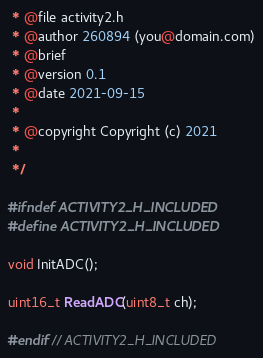<code> <loc_0><loc_0><loc_500><loc_500><_C_> * @file activity2.h
 * @author 260894 (you@domain.com)
 * @brief
 * @version 0.1
 * @date 2021-09-15
 *
 * @copyright Copyright (c) 2021
 *
 */

#ifndef ACTIVITY2_H_INCLUDED
#define ACTIVITY2_H_INCLUDED

void InitADC();

uint16_t ReadADC(uint8_t ch);

#endif // ACTIVITY2_H_INCLUDED
</code> 